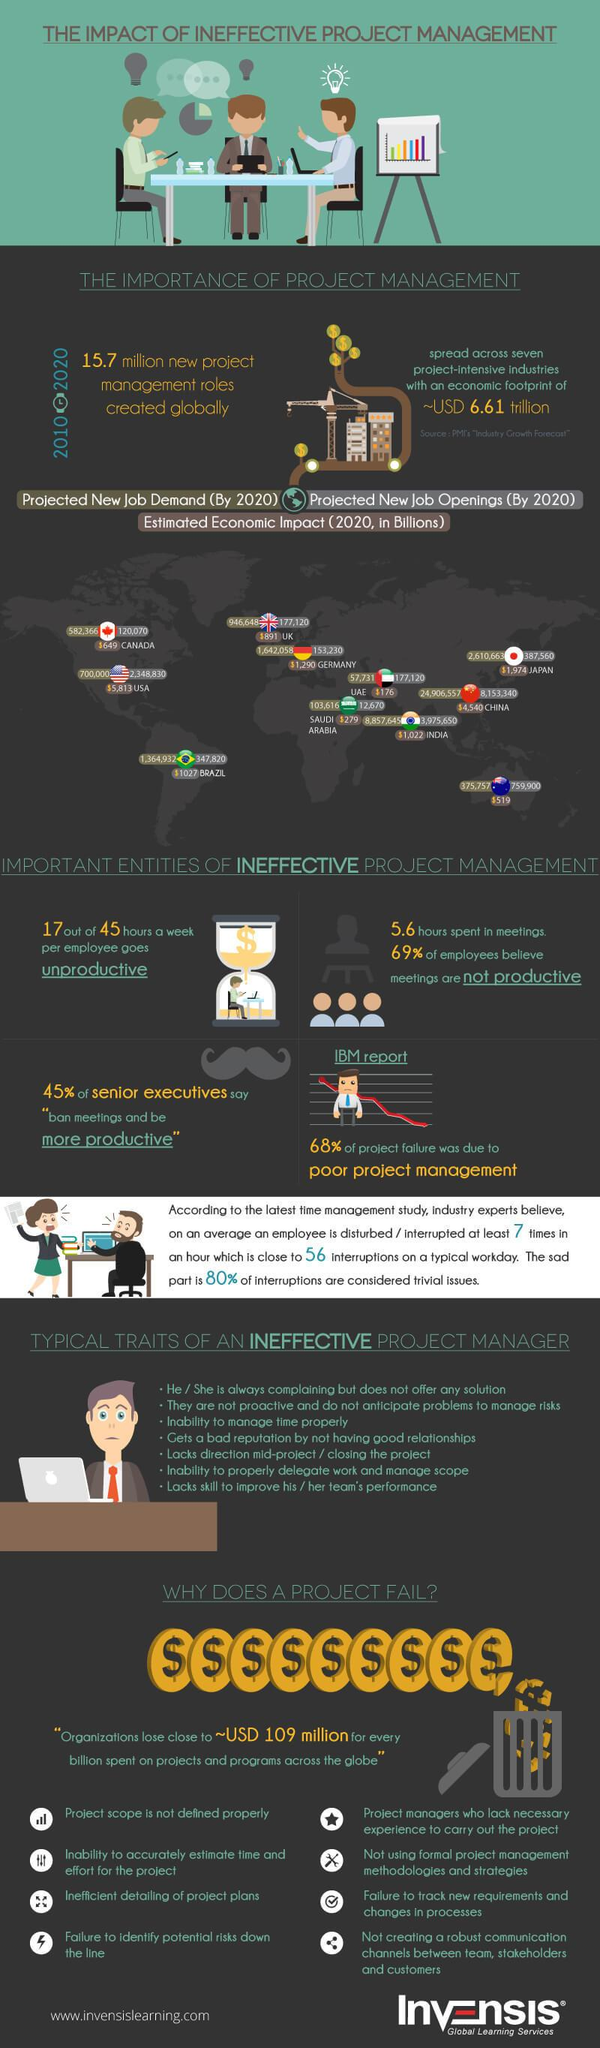Outline some significant characteristics in this image. In 2020, the projected new job demand in the United States is expected to be 642,269, while the projected new job demand in the UAE is expected to be significantly higher at [insert number]. According to projections, it is estimated that the demand for jobs in Canada will increase to approximately 582,366 by the year 2020. The economic impact of China and India in 2020 was significant, with China generating $3518 billion and India generating $2503 billion in value. The projected new job openings in China by 2020 are expected to be approximately 8,153,340. In 2020, Japan is projected to have 210,440 new job openings, while the UK is expected to have significantly fewer, at an estimated 132,680. 